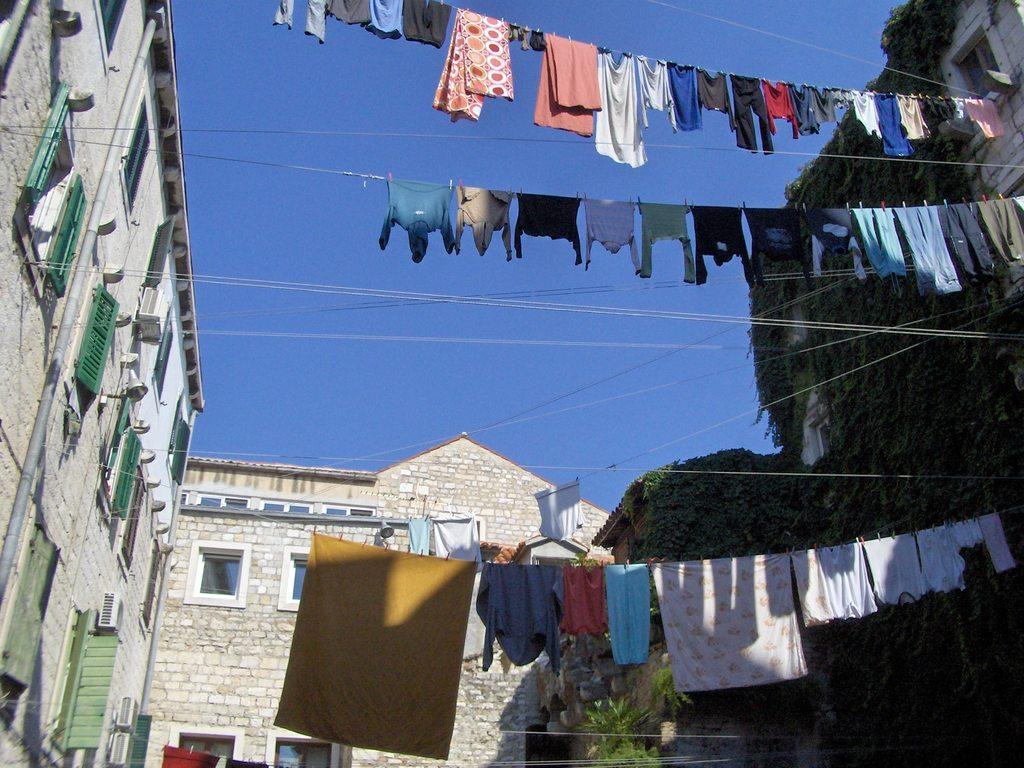Could you give a brief overview of what you see in this image? In this picture we can see buildings, on the right side there are some plants, we can see wires and clothes in the middle, there is the sky at the top of the picture, we can see windows of this building. 